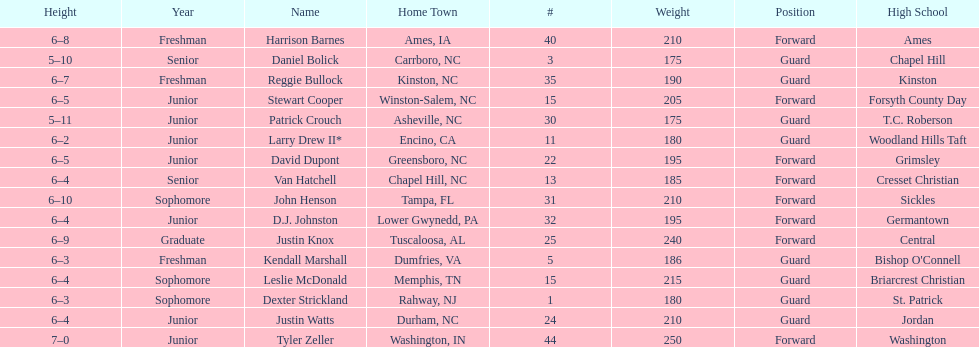What was the number of freshmen on the team? 3. 